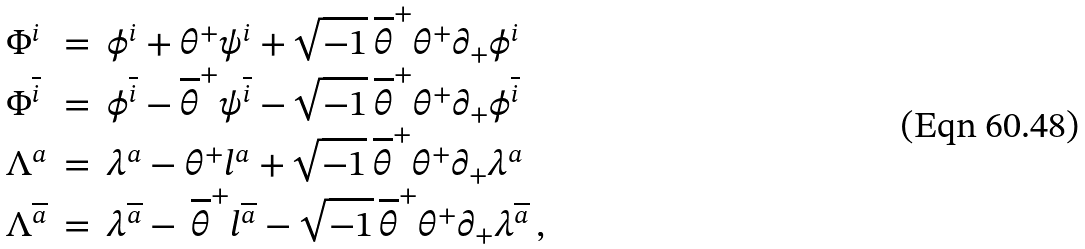<formula> <loc_0><loc_0><loc_500><loc_500>\begin{array} { l l l } \Phi ^ { i } & = & \phi ^ { i } + \theta ^ { + } \psi ^ { i } + \sqrt { - 1 } \, \overline { \theta } ^ { + } \theta ^ { + } \partial _ { + } \phi ^ { i } \\ \Phi ^ { \overline { i } } & = & \phi ^ { \overline { i } } - \overline { \theta } ^ { + } \psi ^ { \overline { i } } - \sqrt { - 1 } \, \overline { \theta } ^ { + } \theta ^ { + } \partial _ { + } \phi ^ { \overline { i } } \\ \Lambda ^ { a } & = & \lambda ^ { a } - \theta ^ { + } l ^ { a } + \sqrt { - 1 } \, \overline { \theta } ^ { + } \theta ^ { + } \partial _ { + } \lambda ^ { a } \\ \Lambda ^ { \overline { a } } & = & \lambda ^ { \overline { a } } - \, \overline { \theta } ^ { + } l ^ { \overline { a } } - \sqrt { - 1 } \, \overline { \theta } ^ { + } \theta ^ { + } \partial _ { + } \lambda ^ { \overline { a } } \, , \end{array}</formula> 